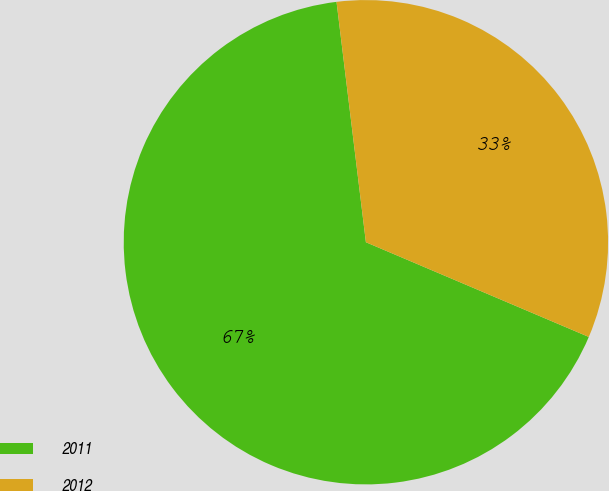<chart> <loc_0><loc_0><loc_500><loc_500><pie_chart><fcel>2011<fcel>2012<nl><fcel>66.67%<fcel>33.33%<nl></chart> 